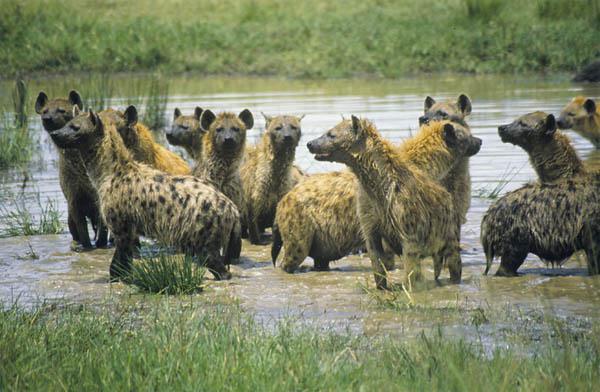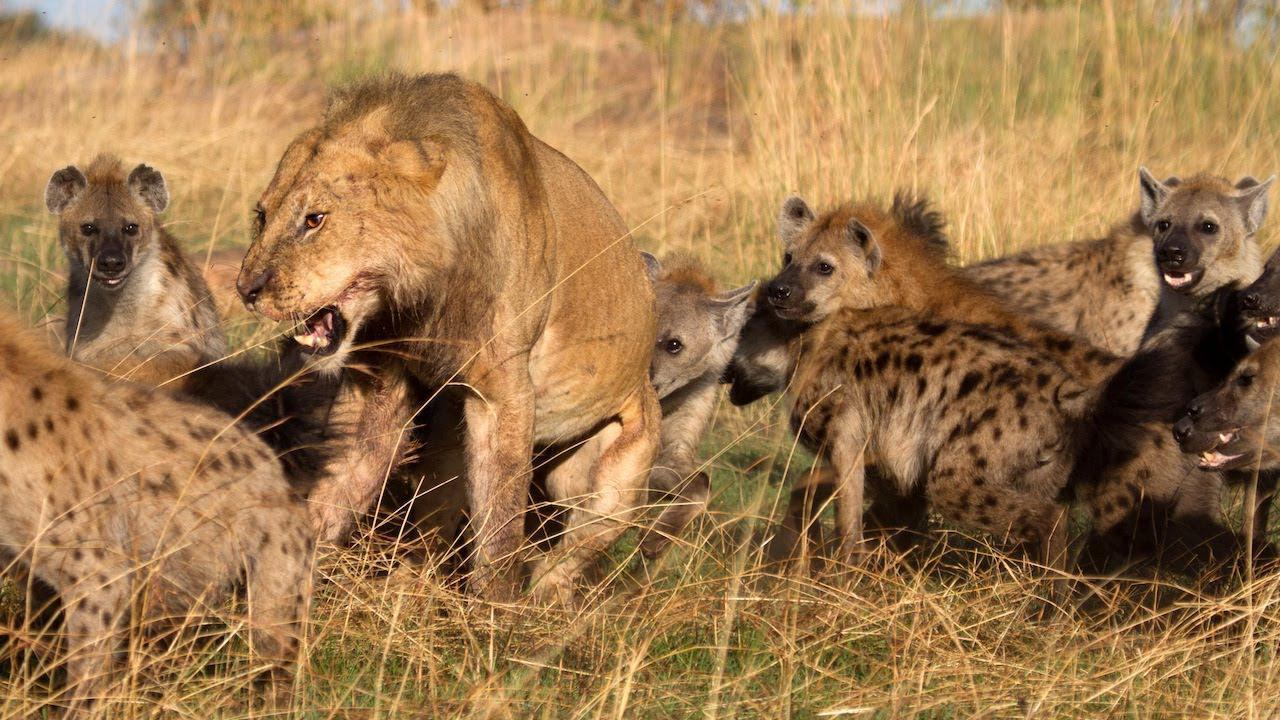The first image is the image on the left, the second image is the image on the right. For the images shown, is this caption "One group of animals is standing in the water." true? Answer yes or no. Yes. 